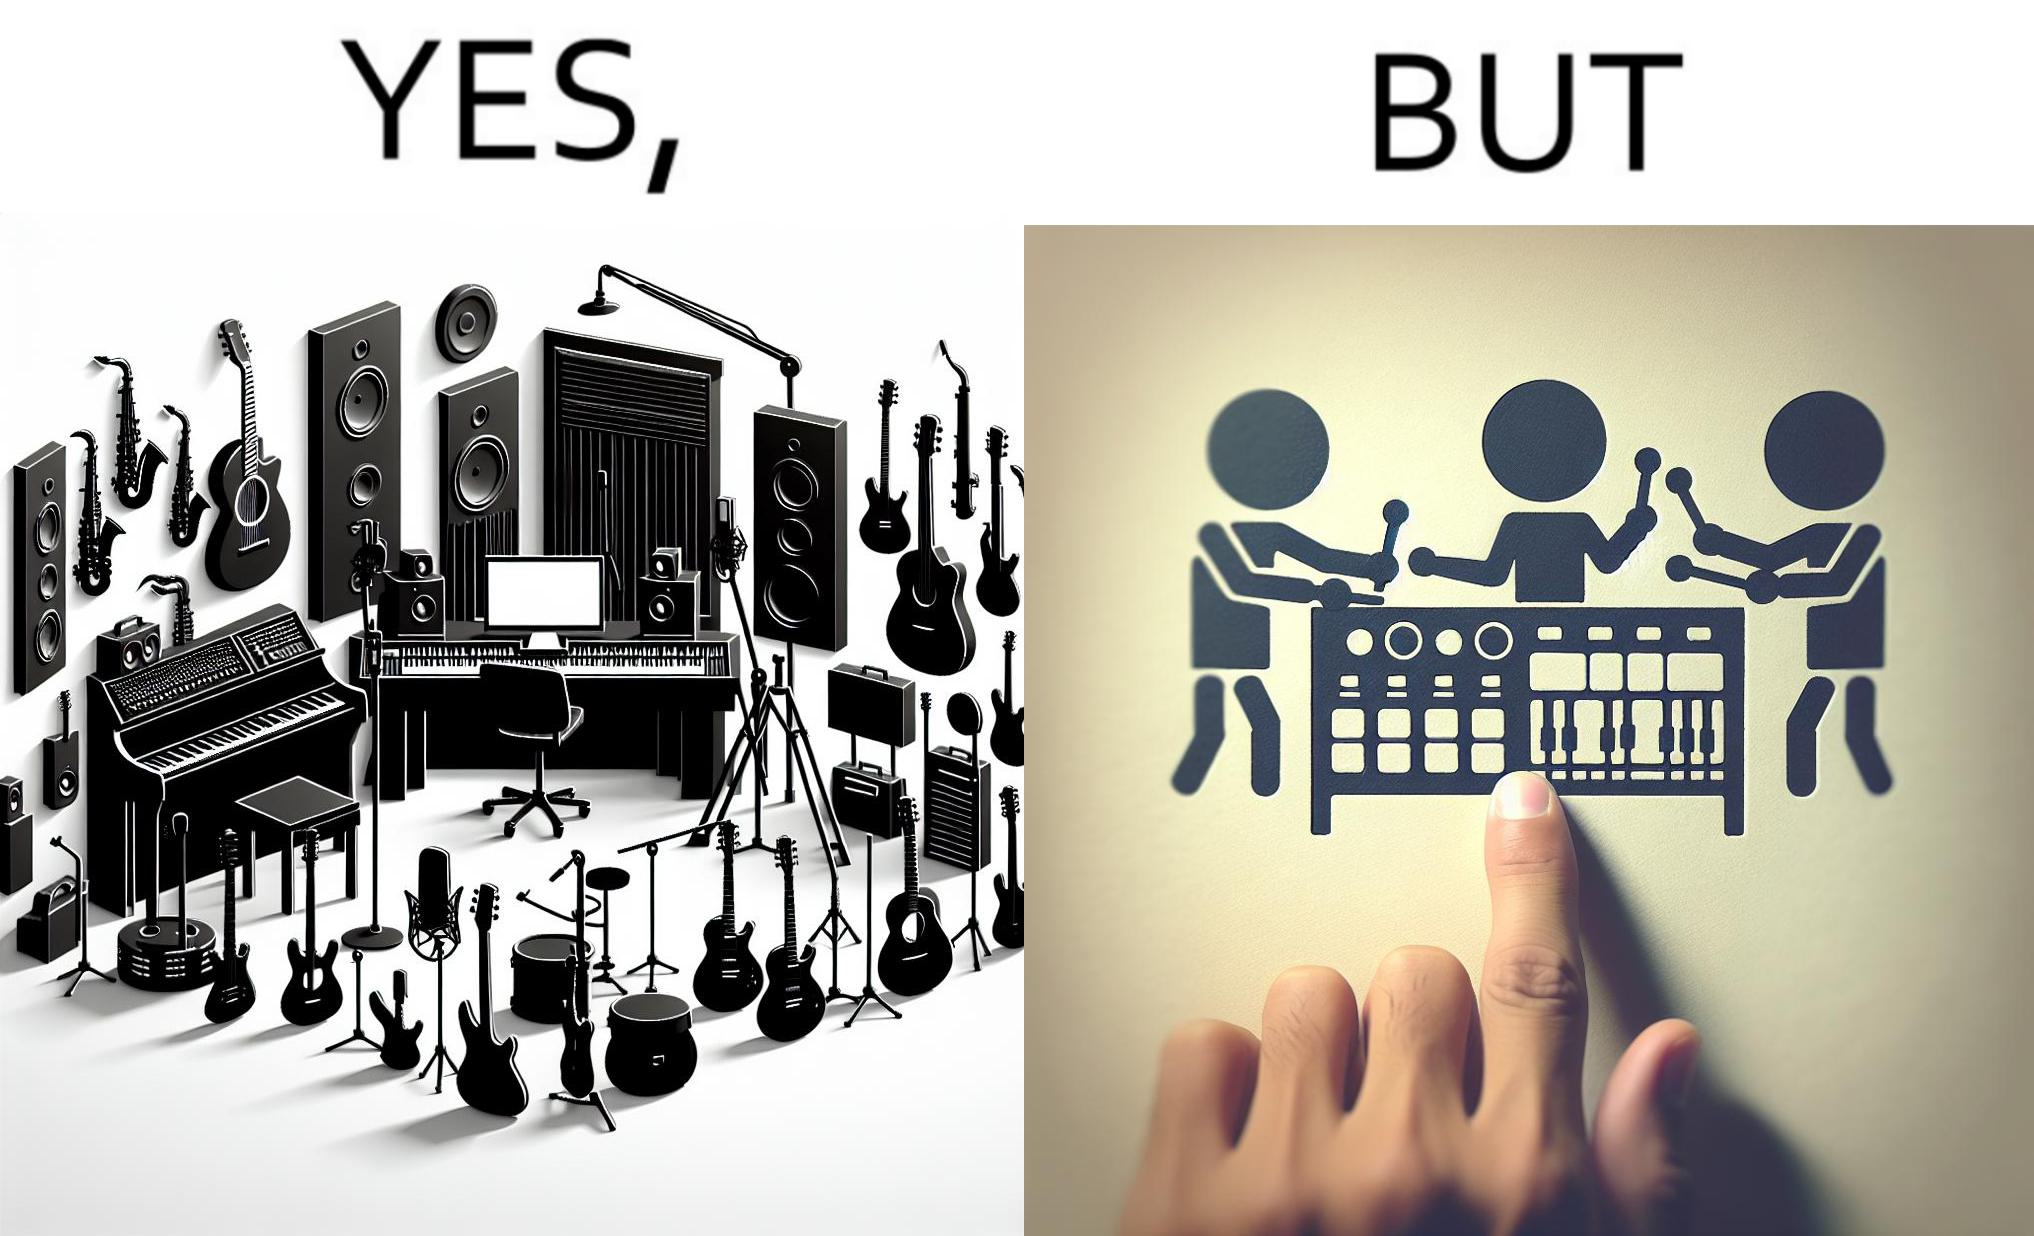What is shown in this image? The image overall is funny because even though people have great music studios and instruments to create and record music, they use electronic replacements of the musical instruments to achieve the task. 